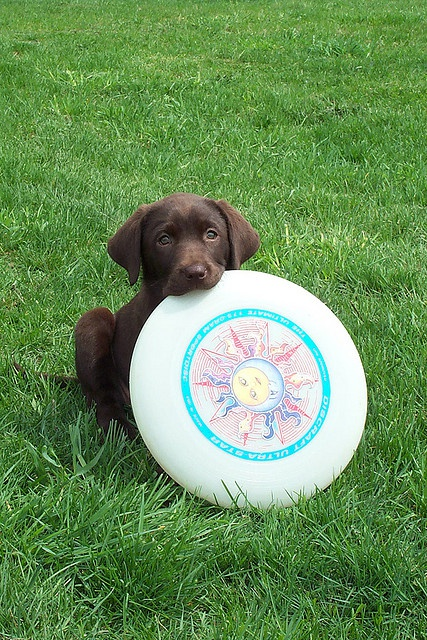Describe the objects in this image and their specific colors. I can see frisbee in green, white, cyan, lightblue, and darkgray tones and dog in green, black, and gray tones in this image. 